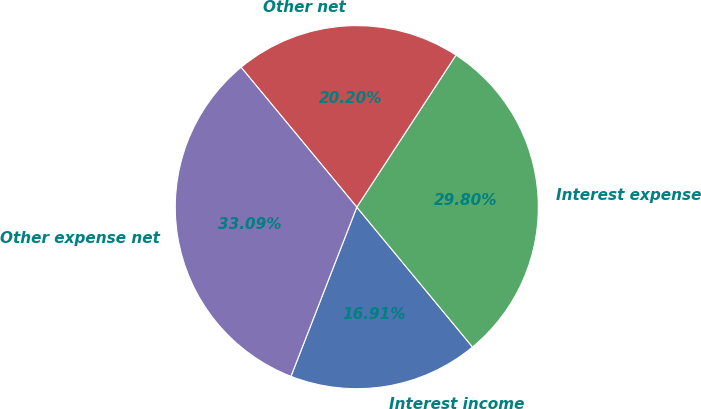<chart> <loc_0><loc_0><loc_500><loc_500><pie_chart><fcel>Interest income<fcel>Interest expense<fcel>Other net<fcel>Other expense net<nl><fcel>16.91%<fcel>29.8%<fcel>20.2%<fcel>33.09%<nl></chart> 